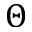<formula> <loc_0><loc_0><loc_500><loc_500>\Theta</formula> 